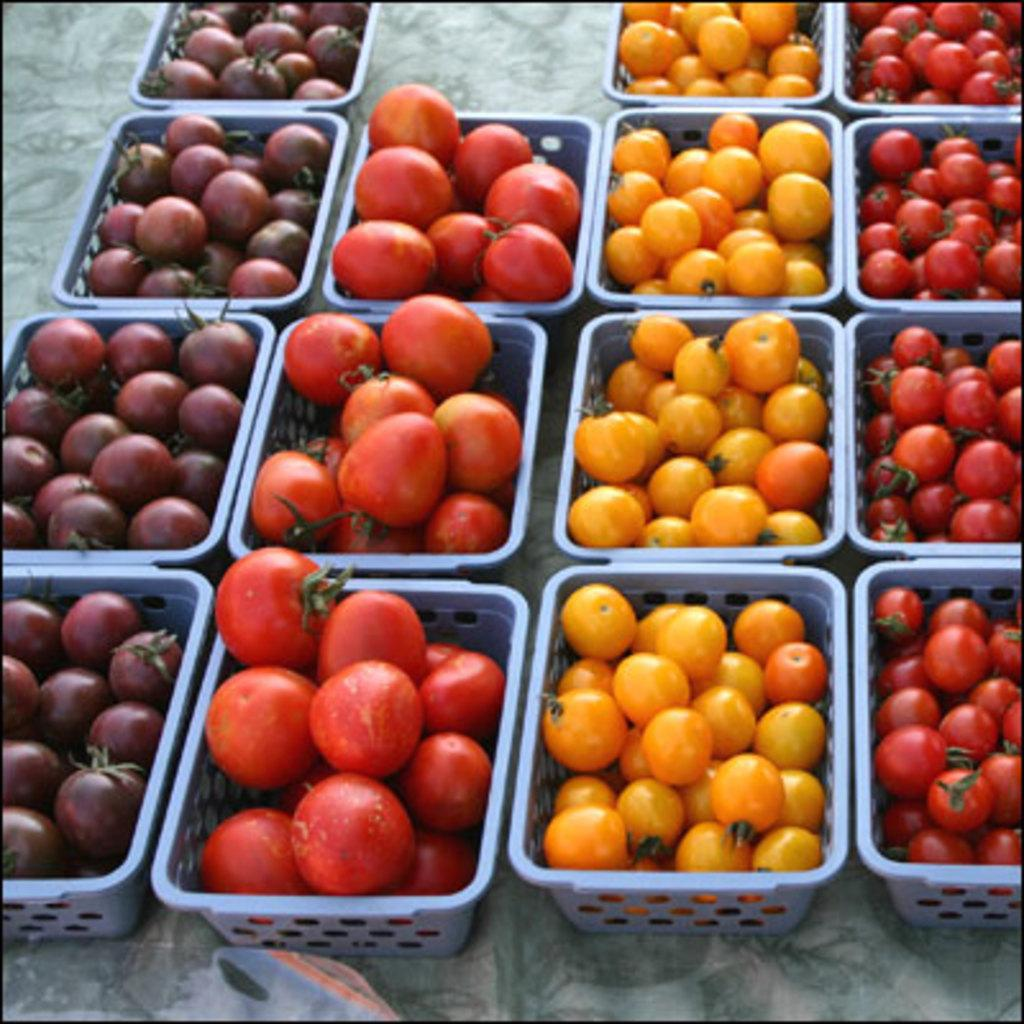What objects are present in the image? There are baskets in the image. What are the baskets containing? The baskets contain different types of tomatoes. Are there any icicles hanging from the tomatoes in the image? No, there are no icicles present in the image. 